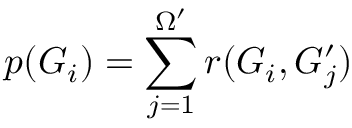<formula> <loc_0><loc_0><loc_500><loc_500>p ( G _ { i } ) = \sum _ { j = 1 } ^ { \Omega ^ { \prime } } r ( G _ { i } , G _ { j } ^ { \prime } )</formula> 